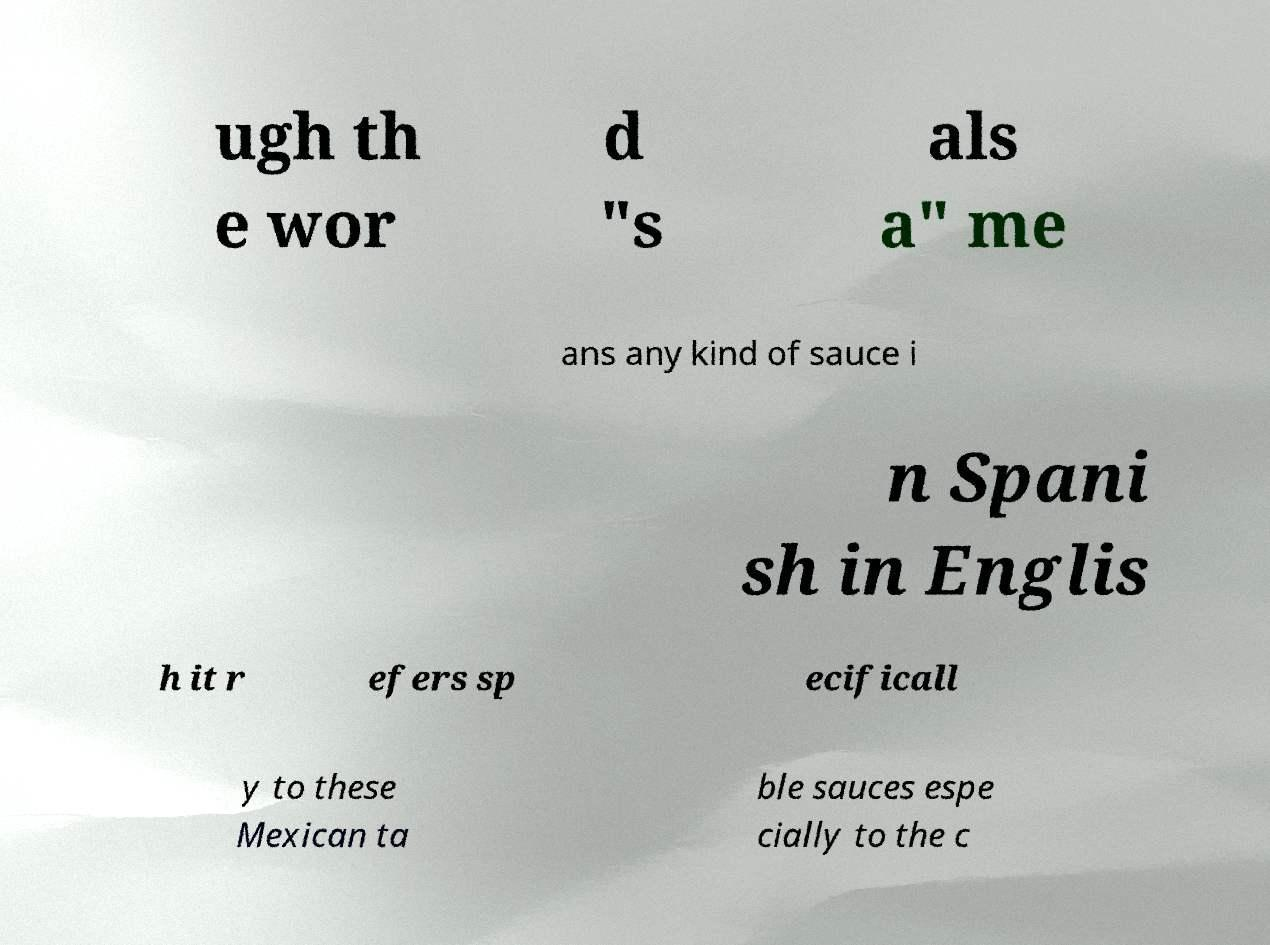Could you assist in decoding the text presented in this image and type it out clearly? ugh th e wor d "s als a" me ans any kind of sauce i n Spani sh in Englis h it r efers sp ecificall y to these Mexican ta ble sauces espe cially to the c 